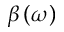Convert formula to latex. <formula><loc_0><loc_0><loc_500><loc_500>\beta \left ( \omega \right )</formula> 